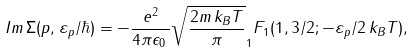Convert formula to latex. <formula><loc_0><loc_0><loc_500><loc_500>I m \, \Sigma ( p , \varepsilon _ { p } / \hbar { ) } = - \frac { e ^ { 2 } } { 4 \pi \epsilon _ { 0 } \, } \sqrt { \frac { 2 m \, k _ { B } T } { \pi } } _ { 1 } F _ { 1 } ( 1 , 3 / 2 ; - \varepsilon _ { p } / 2 \, k _ { B } T ) ,</formula> 